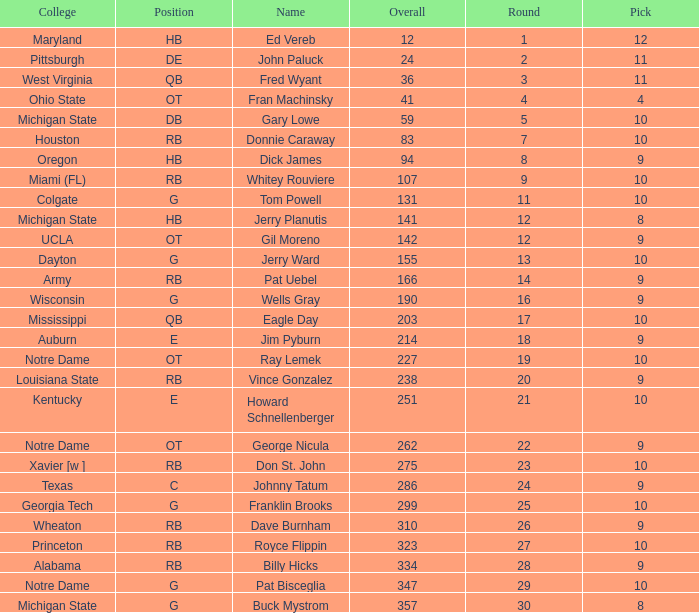What is the overall pick number for a draft pick smaller than 9, named buck mystrom from Michigan State college? 357.0. 